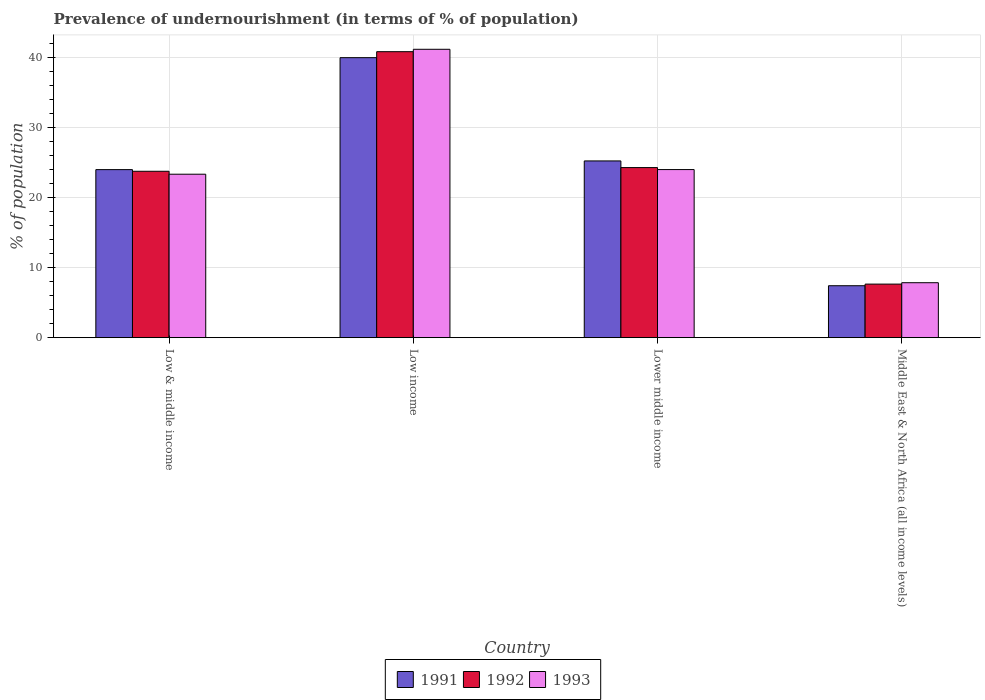How many groups of bars are there?
Offer a terse response. 4. What is the label of the 2nd group of bars from the left?
Ensure brevity in your answer.  Low income. In how many cases, is the number of bars for a given country not equal to the number of legend labels?
Provide a short and direct response. 0. What is the percentage of undernourished population in 1993 in Low income?
Keep it short and to the point. 41.23. Across all countries, what is the maximum percentage of undernourished population in 1992?
Offer a very short reply. 40.89. Across all countries, what is the minimum percentage of undernourished population in 1993?
Provide a succinct answer. 7.86. In which country was the percentage of undernourished population in 1993 maximum?
Your answer should be compact. Low income. In which country was the percentage of undernourished population in 1991 minimum?
Offer a very short reply. Middle East & North Africa (all income levels). What is the total percentage of undernourished population in 1992 in the graph?
Your response must be concise. 96.65. What is the difference between the percentage of undernourished population in 1993 in Low & middle income and that in Low income?
Your response must be concise. -17.86. What is the difference between the percentage of undernourished population in 1992 in Lower middle income and the percentage of undernourished population in 1991 in Middle East & North Africa (all income levels)?
Ensure brevity in your answer.  16.89. What is the average percentage of undernourished population in 1993 per country?
Keep it short and to the point. 24.12. What is the difference between the percentage of undernourished population of/in 1993 and percentage of undernourished population of/in 1991 in Low & middle income?
Make the answer very short. -0.66. What is the ratio of the percentage of undernourished population in 1993 in Low & middle income to that in Low income?
Make the answer very short. 0.57. What is the difference between the highest and the second highest percentage of undernourished population in 1992?
Provide a succinct answer. 16.57. What is the difference between the highest and the lowest percentage of undernourished population in 1992?
Ensure brevity in your answer.  33.23. In how many countries, is the percentage of undernourished population in 1993 greater than the average percentage of undernourished population in 1993 taken over all countries?
Give a very brief answer. 1. Is the sum of the percentage of undernourished population in 1993 in Low income and Middle East & North Africa (all income levels) greater than the maximum percentage of undernourished population in 1992 across all countries?
Your answer should be compact. Yes. What does the 3rd bar from the left in Middle East & North Africa (all income levels) represents?
Your response must be concise. 1993. What does the 3rd bar from the right in Low & middle income represents?
Your response must be concise. 1991. Is it the case that in every country, the sum of the percentage of undernourished population in 1991 and percentage of undernourished population in 1992 is greater than the percentage of undernourished population in 1993?
Your answer should be very brief. Yes. How many bars are there?
Ensure brevity in your answer.  12. How many countries are there in the graph?
Your response must be concise. 4. What is the difference between two consecutive major ticks on the Y-axis?
Provide a short and direct response. 10. Does the graph contain any zero values?
Give a very brief answer. No. What is the title of the graph?
Offer a very short reply. Prevalence of undernourishment (in terms of % of population). What is the label or title of the X-axis?
Your response must be concise. Country. What is the label or title of the Y-axis?
Ensure brevity in your answer.  % of population. What is the % of population in 1991 in Low & middle income?
Provide a short and direct response. 24.03. What is the % of population in 1992 in Low & middle income?
Offer a very short reply. 23.79. What is the % of population of 1993 in Low & middle income?
Keep it short and to the point. 23.37. What is the % of population of 1991 in Low income?
Make the answer very short. 40.03. What is the % of population in 1992 in Low income?
Provide a short and direct response. 40.89. What is the % of population in 1993 in Low income?
Your response must be concise. 41.23. What is the % of population in 1991 in Lower middle income?
Offer a very short reply. 25.27. What is the % of population in 1992 in Lower middle income?
Provide a short and direct response. 24.32. What is the % of population in 1993 in Lower middle income?
Keep it short and to the point. 24.03. What is the % of population of 1991 in Middle East & North Africa (all income levels)?
Your response must be concise. 7.43. What is the % of population in 1992 in Middle East & North Africa (all income levels)?
Give a very brief answer. 7.66. What is the % of population of 1993 in Middle East & North Africa (all income levels)?
Keep it short and to the point. 7.86. Across all countries, what is the maximum % of population in 1991?
Ensure brevity in your answer.  40.03. Across all countries, what is the maximum % of population in 1992?
Provide a short and direct response. 40.89. Across all countries, what is the maximum % of population in 1993?
Provide a succinct answer. 41.23. Across all countries, what is the minimum % of population in 1991?
Provide a short and direct response. 7.43. Across all countries, what is the minimum % of population in 1992?
Make the answer very short. 7.66. Across all countries, what is the minimum % of population in 1993?
Offer a very short reply. 7.86. What is the total % of population of 1991 in the graph?
Make the answer very short. 96.75. What is the total % of population in 1992 in the graph?
Offer a very short reply. 96.65. What is the total % of population in 1993 in the graph?
Your answer should be compact. 96.49. What is the difference between the % of population of 1991 in Low & middle income and that in Low income?
Make the answer very short. -16. What is the difference between the % of population of 1992 in Low & middle income and that in Low income?
Ensure brevity in your answer.  -17.1. What is the difference between the % of population in 1993 in Low & middle income and that in Low income?
Offer a terse response. -17.86. What is the difference between the % of population in 1991 in Low & middle income and that in Lower middle income?
Keep it short and to the point. -1.24. What is the difference between the % of population in 1992 in Low & middle income and that in Lower middle income?
Offer a terse response. -0.53. What is the difference between the % of population in 1993 in Low & middle income and that in Lower middle income?
Provide a short and direct response. -0.66. What is the difference between the % of population in 1991 in Low & middle income and that in Middle East & North Africa (all income levels)?
Provide a succinct answer. 16.6. What is the difference between the % of population in 1992 in Low & middle income and that in Middle East & North Africa (all income levels)?
Your answer should be very brief. 16.13. What is the difference between the % of population of 1993 in Low & middle income and that in Middle East & North Africa (all income levels)?
Offer a very short reply. 15.51. What is the difference between the % of population of 1991 in Low income and that in Lower middle income?
Offer a terse response. 14.76. What is the difference between the % of population of 1992 in Low income and that in Lower middle income?
Offer a very short reply. 16.57. What is the difference between the % of population in 1993 in Low income and that in Lower middle income?
Offer a terse response. 17.2. What is the difference between the % of population of 1991 in Low income and that in Middle East & North Africa (all income levels)?
Provide a succinct answer. 32.61. What is the difference between the % of population in 1992 in Low income and that in Middle East & North Africa (all income levels)?
Keep it short and to the point. 33.23. What is the difference between the % of population of 1993 in Low income and that in Middle East & North Africa (all income levels)?
Offer a terse response. 33.37. What is the difference between the % of population in 1991 in Lower middle income and that in Middle East & North Africa (all income levels)?
Give a very brief answer. 17.84. What is the difference between the % of population in 1992 in Lower middle income and that in Middle East & North Africa (all income levels)?
Keep it short and to the point. 16.66. What is the difference between the % of population of 1993 in Lower middle income and that in Middle East & North Africa (all income levels)?
Offer a very short reply. 16.18. What is the difference between the % of population of 1991 in Low & middle income and the % of population of 1992 in Low income?
Offer a very short reply. -16.86. What is the difference between the % of population of 1991 in Low & middle income and the % of population of 1993 in Low income?
Provide a succinct answer. -17.2. What is the difference between the % of population in 1992 in Low & middle income and the % of population in 1993 in Low income?
Make the answer very short. -17.44. What is the difference between the % of population in 1991 in Low & middle income and the % of population in 1992 in Lower middle income?
Your response must be concise. -0.29. What is the difference between the % of population of 1991 in Low & middle income and the % of population of 1993 in Lower middle income?
Your answer should be very brief. -0.01. What is the difference between the % of population in 1992 in Low & middle income and the % of population in 1993 in Lower middle income?
Provide a succinct answer. -0.25. What is the difference between the % of population of 1991 in Low & middle income and the % of population of 1992 in Middle East & North Africa (all income levels)?
Provide a succinct answer. 16.37. What is the difference between the % of population in 1991 in Low & middle income and the % of population in 1993 in Middle East & North Africa (all income levels)?
Your answer should be compact. 16.17. What is the difference between the % of population of 1992 in Low & middle income and the % of population of 1993 in Middle East & North Africa (all income levels)?
Ensure brevity in your answer.  15.93. What is the difference between the % of population in 1991 in Low income and the % of population in 1992 in Lower middle income?
Ensure brevity in your answer.  15.71. What is the difference between the % of population in 1991 in Low income and the % of population in 1993 in Lower middle income?
Offer a terse response. 16. What is the difference between the % of population in 1992 in Low income and the % of population in 1993 in Lower middle income?
Provide a succinct answer. 16.85. What is the difference between the % of population of 1991 in Low income and the % of population of 1992 in Middle East & North Africa (all income levels)?
Offer a terse response. 32.37. What is the difference between the % of population of 1991 in Low income and the % of population of 1993 in Middle East & North Africa (all income levels)?
Your answer should be compact. 32.17. What is the difference between the % of population of 1992 in Low income and the % of population of 1993 in Middle East & North Africa (all income levels)?
Provide a succinct answer. 33.03. What is the difference between the % of population in 1991 in Lower middle income and the % of population in 1992 in Middle East & North Africa (all income levels)?
Provide a short and direct response. 17.61. What is the difference between the % of population in 1991 in Lower middle income and the % of population in 1993 in Middle East & North Africa (all income levels)?
Your answer should be very brief. 17.41. What is the difference between the % of population of 1992 in Lower middle income and the % of population of 1993 in Middle East & North Africa (all income levels)?
Give a very brief answer. 16.46. What is the average % of population of 1991 per country?
Offer a very short reply. 24.19. What is the average % of population in 1992 per country?
Give a very brief answer. 24.16. What is the average % of population in 1993 per country?
Offer a very short reply. 24.12. What is the difference between the % of population in 1991 and % of population in 1992 in Low & middle income?
Give a very brief answer. 0.24. What is the difference between the % of population in 1991 and % of population in 1993 in Low & middle income?
Provide a short and direct response. 0.66. What is the difference between the % of population in 1992 and % of population in 1993 in Low & middle income?
Offer a very short reply. 0.42. What is the difference between the % of population of 1991 and % of population of 1992 in Low income?
Give a very brief answer. -0.86. What is the difference between the % of population in 1991 and % of population in 1993 in Low income?
Provide a short and direct response. -1.2. What is the difference between the % of population in 1992 and % of population in 1993 in Low income?
Your answer should be compact. -0.34. What is the difference between the % of population of 1991 and % of population of 1992 in Lower middle income?
Your answer should be very brief. 0.95. What is the difference between the % of population of 1991 and % of population of 1993 in Lower middle income?
Ensure brevity in your answer.  1.23. What is the difference between the % of population of 1992 and % of population of 1993 in Lower middle income?
Give a very brief answer. 0.28. What is the difference between the % of population in 1991 and % of population in 1992 in Middle East & North Africa (all income levels)?
Give a very brief answer. -0.23. What is the difference between the % of population in 1991 and % of population in 1993 in Middle East & North Africa (all income levels)?
Offer a very short reply. -0.43. What is the difference between the % of population in 1992 and % of population in 1993 in Middle East & North Africa (all income levels)?
Ensure brevity in your answer.  -0.2. What is the ratio of the % of population in 1991 in Low & middle income to that in Low income?
Make the answer very short. 0.6. What is the ratio of the % of population in 1992 in Low & middle income to that in Low income?
Your answer should be very brief. 0.58. What is the ratio of the % of population in 1993 in Low & middle income to that in Low income?
Provide a succinct answer. 0.57. What is the ratio of the % of population of 1991 in Low & middle income to that in Lower middle income?
Give a very brief answer. 0.95. What is the ratio of the % of population of 1992 in Low & middle income to that in Lower middle income?
Provide a succinct answer. 0.98. What is the ratio of the % of population in 1993 in Low & middle income to that in Lower middle income?
Make the answer very short. 0.97. What is the ratio of the % of population of 1991 in Low & middle income to that in Middle East & North Africa (all income levels)?
Make the answer very short. 3.24. What is the ratio of the % of population in 1992 in Low & middle income to that in Middle East & North Africa (all income levels)?
Your answer should be compact. 3.11. What is the ratio of the % of population of 1993 in Low & middle income to that in Middle East & North Africa (all income levels)?
Give a very brief answer. 2.97. What is the ratio of the % of population of 1991 in Low income to that in Lower middle income?
Provide a short and direct response. 1.58. What is the ratio of the % of population of 1992 in Low income to that in Lower middle income?
Provide a short and direct response. 1.68. What is the ratio of the % of population in 1993 in Low income to that in Lower middle income?
Your answer should be very brief. 1.72. What is the ratio of the % of population of 1991 in Low income to that in Middle East & North Africa (all income levels)?
Keep it short and to the point. 5.39. What is the ratio of the % of population in 1992 in Low income to that in Middle East & North Africa (all income levels)?
Give a very brief answer. 5.34. What is the ratio of the % of population in 1993 in Low income to that in Middle East & North Africa (all income levels)?
Make the answer very short. 5.25. What is the ratio of the % of population in 1991 in Lower middle income to that in Middle East & North Africa (all income levels)?
Keep it short and to the point. 3.4. What is the ratio of the % of population of 1992 in Lower middle income to that in Middle East & North Africa (all income levels)?
Provide a succinct answer. 3.18. What is the ratio of the % of population of 1993 in Lower middle income to that in Middle East & North Africa (all income levels)?
Your answer should be compact. 3.06. What is the difference between the highest and the second highest % of population of 1991?
Provide a succinct answer. 14.76. What is the difference between the highest and the second highest % of population of 1992?
Make the answer very short. 16.57. What is the difference between the highest and the second highest % of population of 1993?
Your response must be concise. 17.2. What is the difference between the highest and the lowest % of population in 1991?
Give a very brief answer. 32.61. What is the difference between the highest and the lowest % of population in 1992?
Your answer should be compact. 33.23. What is the difference between the highest and the lowest % of population of 1993?
Ensure brevity in your answer.  33.37. 